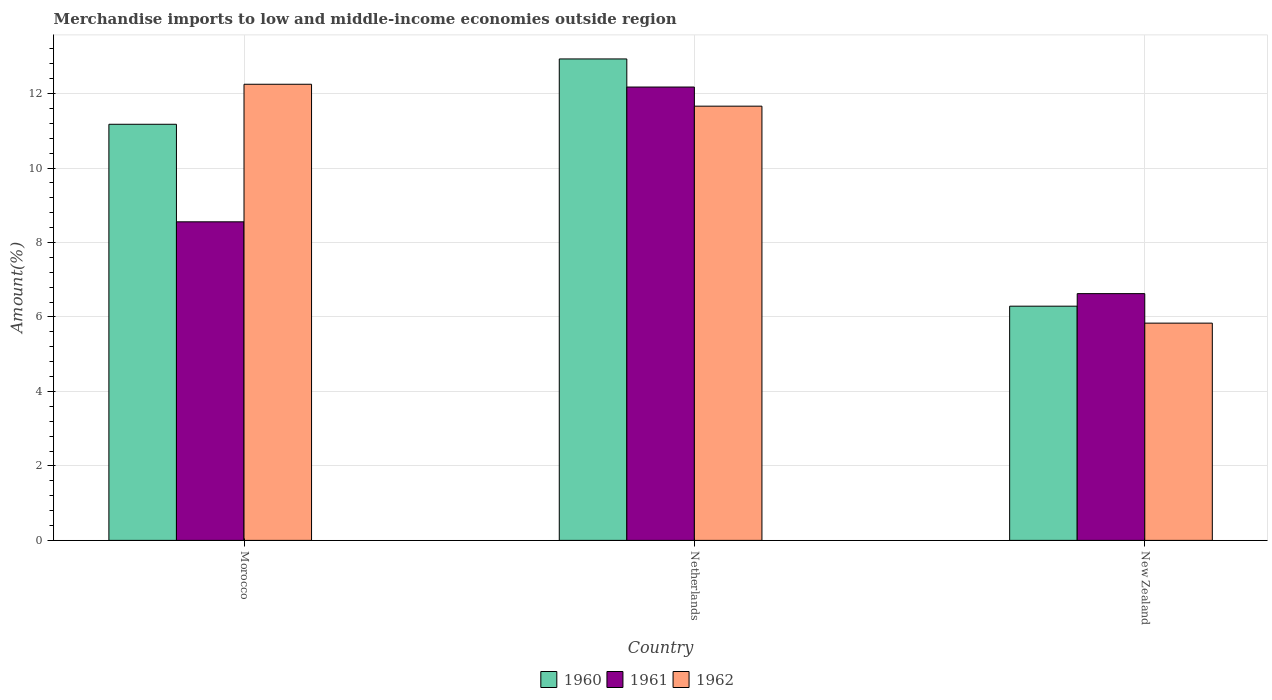Are the number of bars per tick equal to the number of legend labels?
Provide a succinct answer. Yes. Are the number of bars on each tick of the X-axis equal?
Make the answer very short. Yes. How many bars are there on the 3rd tick from the left?
Make the answer very short. 3. How many bars are there on the 3rd tick from the right?
Offer a very short reply. 3. What is the label of the 1st group of bars from the left?
Your response must be concise. Morocco. In how many cases, is the number of bars for a given country not equal to the number of legend labels?
Make the answer very short. 0. What is the percentage of amount earned from merchandise imports in 1961 in Morocco?
Provide a short and direct response. 8.56. Across all countries, what is the maximum percentage of amount earned from merchandise imports in 1962?
Offer a terse response. 12.25. Across all countries, what is the minimum percentage of amount earned from merchandise imports in 1960?
Offer a very short reply. 6.29. In which country was the percentage of amount earned from merchandise imports in 1960 maximum?
Your answer should be very brief. Netherlands. In which country was the percentage of amount earned from merchandise imports in 1961 minimum?
Give a very brief answer. New Zealand. What is the total percentage of amount earned from merchandise imports in 1962 in the graph?
Your response must be concise. 29.75. What is the difference between the percentage of amount earned from merchandise imports in 1960 in Netherlands and that in New Zealand?
Your answer should be compact. 6.64. What is the difference between the percentage of amount earned from merchandise imports in 1962 in New Zealand and the percentage of amount earned from merchandise imports in 1961 in Netherlands?
Your response must be concise. -6.34. What is the average percentage of amount earned from merchandise imports in 1961 per country?
Provide a short and direct response. 9.12. What is the difference between the percentage of amount earned from merchandise imports of/in 1962 and percentage of amount earned from merchandise imports of/in 1961 in Morocco?
Offer a very short reply. 3.69. In how many countries, is the percentage of amount earned from merchandise imports in 1962 greater than 0.4 %?
Your answer should be compact. 3. What is the ratio of the percentage of amount earned from merchandise imports in 1962 in Morocco to that in New Zealand?
Provide a short and direct response. 2.1. Is the percentage of amount earned from merchandise imports in 1960 in Netherlands less than that in New Zealand?
Provide a short and direct response. No. What is the difference between the highest and the second highest percentage of amount earned from merchandise imports in 1960?
Your response must be concise. -1.75. What is the difference between the highest and the lowest percentage of amount earned from merchandise imports in 1961?
Provide a succinct answer. 5.55. In how many countries, is the percentage of amount earned from merchandise imports in 1961 greater than the average percentage of amount earned from merchandise imports in 1961 taken over all countries?
Ensure brevity in your answer.  1. What does the 1st bar from the right in Morocco represents?
Provide a succinct answer. 1962. Are all the bars in the graph horizontal?
Your response must be concise. No. Are the values on the major ticks of Y-axis written in scientific E-notation?
Your answer should be compact. No. Does the graph contain any zero values?
Give a very brief answer. No. Does the graph contain grids?
Provide a short and direct response. Yes. How many legend labels are there?
Provide a succinct answer. 3. How are the legend labels stacked?
Provide a short and direct response. Horizontal. What is the title of the graph?
Your response must be concise. Merchandise imports to low and middle-income economies outside region. What is the label or title of the Y-axis?
Offer a very short reply. Amount(%). What is the Amount(%) in 1960 in Morocco?
Give a very brief answer. 11.18. What is the Amount(%) in 1961 in Morocco?
Your response must be concise. 8.56. What is the Amount(%) of 1962 in Morocco?
Ensure brevity in your answer.  12.25. What is the Amount(%) of 1960 in Netherlands?
Your answer should be very brief. 12.93. What is the Amount(%) in 1961 in Netherlands?
Offer a terse response. 12.18. What is the Amount(%) in 1962 in Netherlands?
Make the answer very short. 11.66. What is the Amount(%) of 1960 in New Zealand?
Give a very brief answer. 6.29. What is the Amount(%) of 1961 in New Zealand?
Your answer should be very brief. 6.63. What is the Amount(%) of 1962 in New Zealand?
Offer a terse response. 5.83. Across all countries, what is the maximum Amount(%) in 1960?
Your answer should be very brief. 12.93. Across all countries, what is the maximum Amount(%) of 1961?
Make the answer very short. 12.18. Across all countries, what is the maximum Amount(%) in 1962?
Keep it short and to the point. 12.25. Across all countries, what is the minimum Amount(%) of 1960?
Keep it short and to the point. 6.29. Across all countries, what is the minimum Amount(%) in 1961?
Your answer should be very brief. 6.63. Across all countries, what is the minimum Amount(%) of 1962?
Offer a very short reply. 5.83. What is the total Amount(%) in 1960 in the graph?
Keep it short and to the point. 30.4. What is the total Amount(%) in 1961 in the graph?
Your answer should be very brief. 27.36. What is the total Amount(%) in 1962 in the graph?
Ensure brevity in your answer.  29.75. What is the difference between the Amount(%) in 1960 in Morocco and that in Netherlands?
Your response must be concise. -1.75. What is the difference between the Amount(%) in 1961 in Morocco and that in Netherlands?
Ensure brevity in your answer.  -3.62. What is the difference between the Amount(%) in 1962 in Morocco and that in Netherlands?
Your answer should be very brief. 0.59. What is the difference between the Amount(%) of 1960 in Morocco and that in New Zealand?
Give a very brief answer. 4.89. What is the difference between the Amount(%) in 1961 in Morocco and that in New Zealand?
Keep it short and to the point. 1.93. What is the difference between the Amount(%) of 1962 in Morocco and that in New Zealand?
Your response must be concise. 6.42. What is the difference between the Amount(%) in 1960 in Netherlands and that in New Zealand?
Your answer should be compact. 6.64. What is the difference between the Amount(%) in 1961 in Netherlands and that in New Zealand?
Make the answer very short. 5.55. What is the difference between the Amount(%) in 1962 in Netherlands and that in New Zealand?
Your response must be concise. 5.83. What is the difference between the Amount(%) in 1960 in Morocco and the Amount(%) in 1961 in Netherlands?
Your answer should be very brief. -1. What is the difference between the Amount(%) in 1960 in Morocco and the Amount(%) in 1962 in Netherlands?
Offer a terse response. -0.49. What is the difference between the Amount(%) in 1961 in Morocco and the Amount(%) in 1962 in Netherlands?
Provide a short and direct response. -3.11. What is the difference between the Amount(%) in 1960 in Morocco and the Amount(%) in 1961 in New Zealand?
Give a very brief answer. 4.55. What is the difference between the Amount(%) of 1960 in Morocco and the Amount(%) of 1962 in New Zealand?
Provide a succinct answer. 5.34. What is the difference between the Amount(%) of 1961 in Morocco and the Amount(%) of 1962 in New Zealand?
Keep it short and to the point. 2.72. What is the difference between the Amount(%) in 1960 in Netherlands and the Amount(%) in 1961 in New Zealand?
Make the answer very short. 6.3. What is the difference between the Amount(%) in 1960 in Netherlands and the Amount(%) in 1962 in New Zealand?
Give a very brief answer. 7.1. What is the difference between the Amount(%) of 1961 in Netherlands and the Amount(%) of 1962 in New Zealand?
Make the answer very short. 6.34. What is the average Amount(%) of 1960 per country?
Give a very brief answer. 10.13. What is the average Amount(%) in 1961 per country?
Provide a short and direct response. 9.12. What is the average Amount(%) of 1962 per country?
Provide a succinct answer. 9.92. What is the difference between the Amount(%) in 1960 and Amount(%) in 1961 in Morocco?
Your response must be concise. 2.62. What is the difference between the Amount(%) in 1960 and Amount(%) in 1962 in Morocco?
Provide a short and direct response. -1.07. What is the difference between the Amount(%) in 1961 and Amount(%) in 1962 in Morocco?
Your response must be concise. -3.69. What is the difference between the Amount(%) in 1960 and Amount(%) in 1961 in Netherlands?
Ensure brevity in your answer.  0.75. What is the difference between the Amount(%) of 1960 and Amount(%) of 1962 in Netherlands?
Keep it short and to the point. 1.27. What is the difference between the Amount(%) of 1961 and Amount(%) of 1962 in Netherlands?
Keep it short and to the point. 0.51. What is the difference between the Amount(%) in 1960 and Amount(%) in 1961 in New Zealand?
Your response must be concise. -0.34. What is the difference between the Amount(%) of 1960 and Amount(%) of 1962 in New Zealand?
Give a very brief answer. 0.46. What is the difference between the Amount(%) in 1961 and Amount(%) in 1962 in New Zealand?
Provide a short and direct response. 0.79. What is the ratio of the Amount(%) of 1960 in Morocco to that in Netherlands?
Your answer should be compact. 0.86. What is the ratio of the Amount(%) of 1961 in Morocco to that in Netherlands?
Your response must be concise. 0.7. What is the ratio of the Amount(%) of 1962 in Morocco to that in Netherlands?
Provide a succinct answer. 1.05. What is the ratio of the Amount(%) of 1960 in Morocco to that in New Zealand?
Offer a very short reply. 1.78. What is the ratio of the Amount(%) in 1961 in Morocco to that in New Zealand?
Offer a very short reply. 1.29. What is the ratio of the Amount(%) of 1962 in Morocco to that in New Zealand?
Your answer should be very brief. 2.1. What is the ratio of the Amount(%) of 1960 in Netherlands to that in New Zealand?
Your answer should be very brief. 2.06. What is the ratio of the Amount(%) of 1961 in Netherlands to that in New Zealand?
Offer a terse response. 1.84. What is the ratio of the Amount(%) of 1962 in Netherlands to that in New Zealand?
Your response must be concise. 2. What is the difference between the highest and the second highest Amount(%) in 1960?
Provide a short and direct response. 1.75. What is the difference between the highest and the second highest Amount(%) of 1961?
Provide a succinct answer. 3.62. What is the difference between the highest and the second highest Amount(%) in 1962?
Your answer should be very brief. 0.59. What is the difference between the highest and the lowest Amount(%) in 1960?
Keep it short and to the point. 6.64. What is the difference between the highest and the lowest Amount(%) of 1961?
Your answer should be very brief. 5.55. What is the difference between the highest and the lowest Amount(%) in 1962?
Provide a succinct answer. 6.42. 